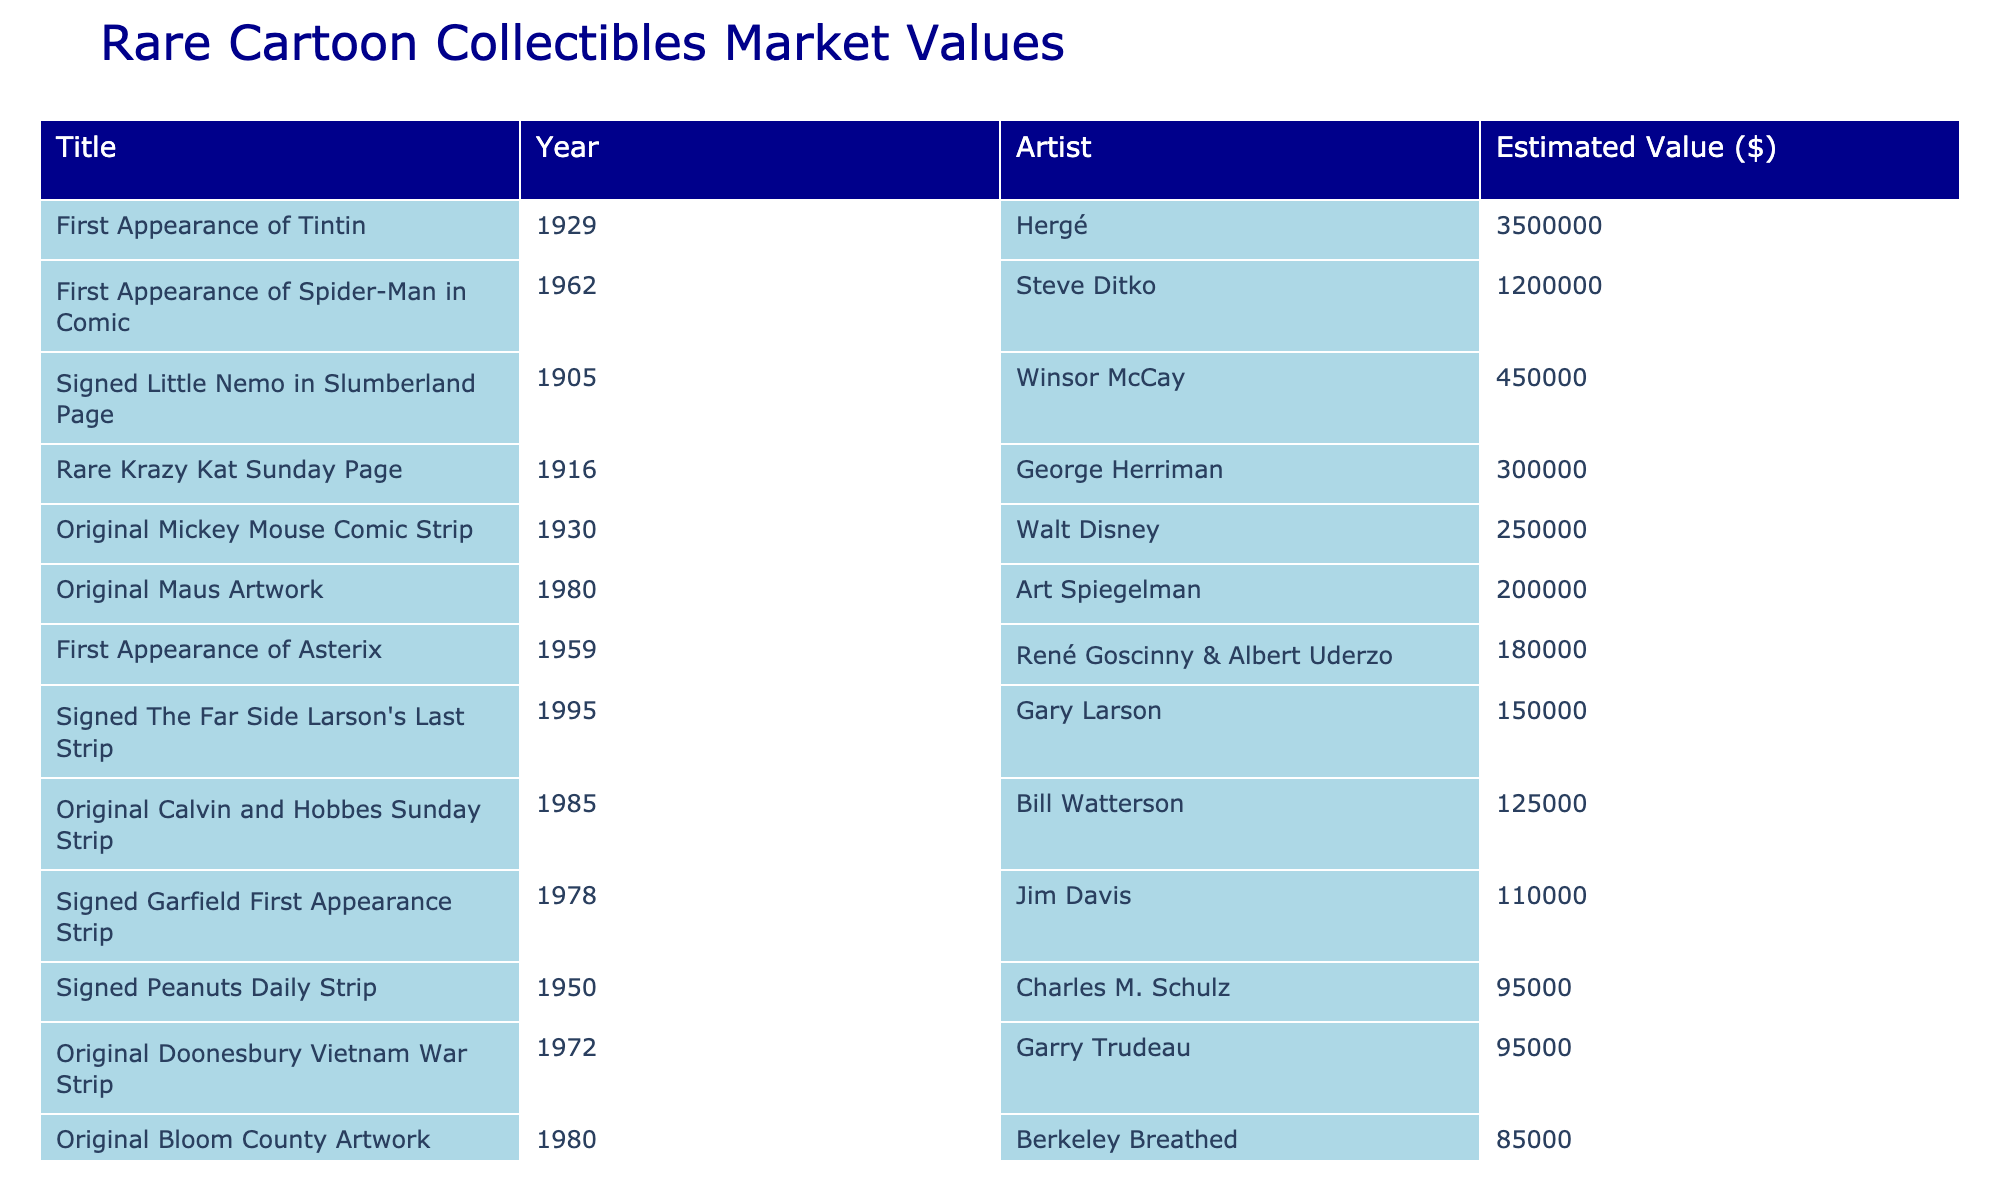What is the estimated value of the Original Calvin and Hobbes Sunday Strip? The table shows the estimated value listed next to the title "Original Calvin and Hobbes Sunday Strip," which is $125,000.
Answer: $125,000 Who is the artist of the First Appearance of Tintin? The table indicates that the artist associated with the title "First Appearance of Tintin" is Hergé.
Answer: Hergé What is the total estimated value of the collectibles from the 1980s? We need to sum the estimated values of all items from the 1980s: $125,000 (Calvin and Hobbes) + $75,000 (Far Side Gallery) + $110,000 (Garfield) + $200,000 (Maus) = $510,000.
Answer: $510,000 Is the Signed Peanuts Daily Strip valued higher than the Rare Dilbert Prototype Sketch? The estimated value of the Signed Peanuts Daily Strip is $95,000, which is higher than the Rare Dilbert Prototype Sketch, valued at $60,000.
Answer: Yes What is the difference in estimated value between the First Appearance of Spider-Man in Comic and the First Appearance of Asterix? The values are $1,200,000 (Spider-Man) and $180,000 (Asterix), so the difference is $1,200,000 - $180,000 = $1,020,000.
Answer: $1,020,000 How many collectibles were created before 1950? The table lists three items created before 1950: Signed Little Nemo in Slumberland Page (1905), First Appearance of Tintin (1929), and First Appearance of Asterix (1959). Therefore, there are 3 collectibles.
Answer: 3 What is the average estimated value of the collectibles from the 1900s? The collectibles from the 1900s are: Signed Little Nemo in Slumberland Page ($450,000), First Appearance of Tintin ($3,500,000). Average = ($450,000 + $3,500,000) / 2 = $1,975,000.
Answer: $1,975,000 Which artist has the lowest estimated value in their cartoon collectible? The lowest estimated value is listed for the Rare Dilbert Prototype Sketch by Scott Adams, which is $60,000.
Answer: Scott Adams How many collectibles are valued over $250,000? The table lists the collectibles valued over $250,000: First Appearance of Tintin ($3,500,000), Original Mickey Mouse Comic Strip ($250,000), and First Appearance of Spider-Man in Comic ($1,200,000). This totals 3 collectibles.
Answer: 3 What is the highest estimated value among the collectibles listed? The table shows that the First Appearance of Tintin has the highest estimated value at $3,500,000.
Answer: $3,500,000 